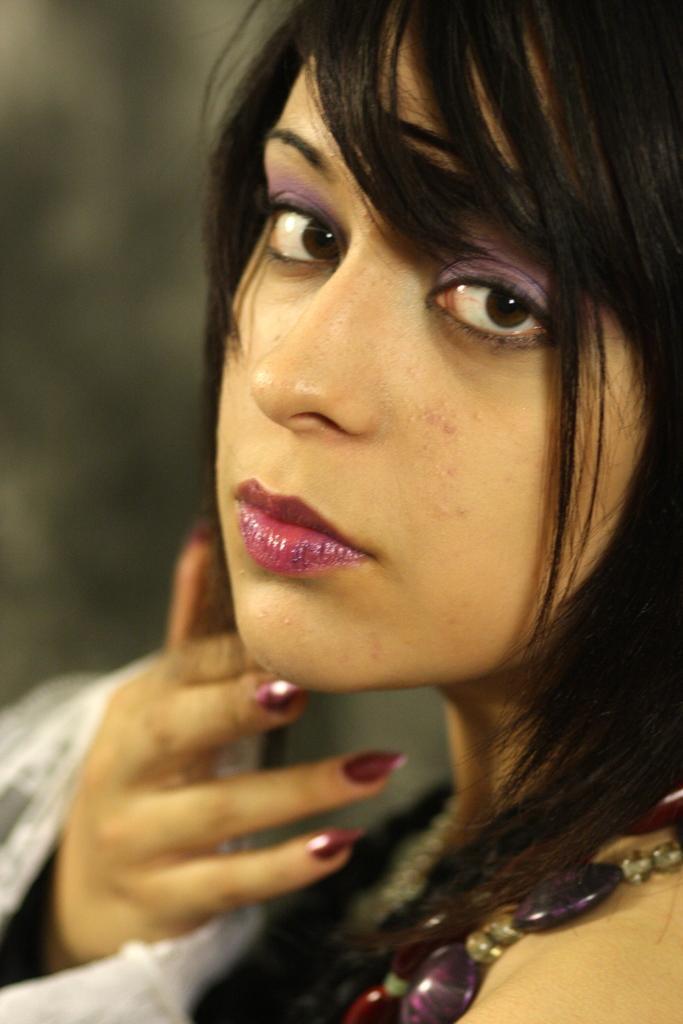Please provide a concise description of this image. There is an image of a women as we can see in the middle of this image. 